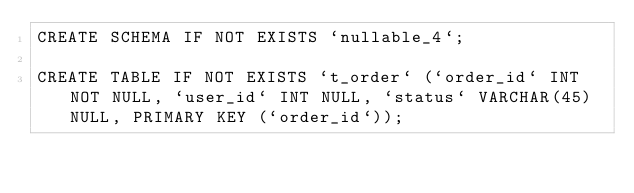Convert code to text. <code><loc_0><loc_0><loc_500><loc_500><_SQL_>CREATE SCHEMA IF NOT EXISTS `nullable_4`;

CREATE TABLE IF NOT EXISTS `t_order` (`order_id` INT NOT NULL, `user_id` INT NULL, `status` VARCHAR(45) NULL, PRIMARY KEY (`order_id`));
</code> 